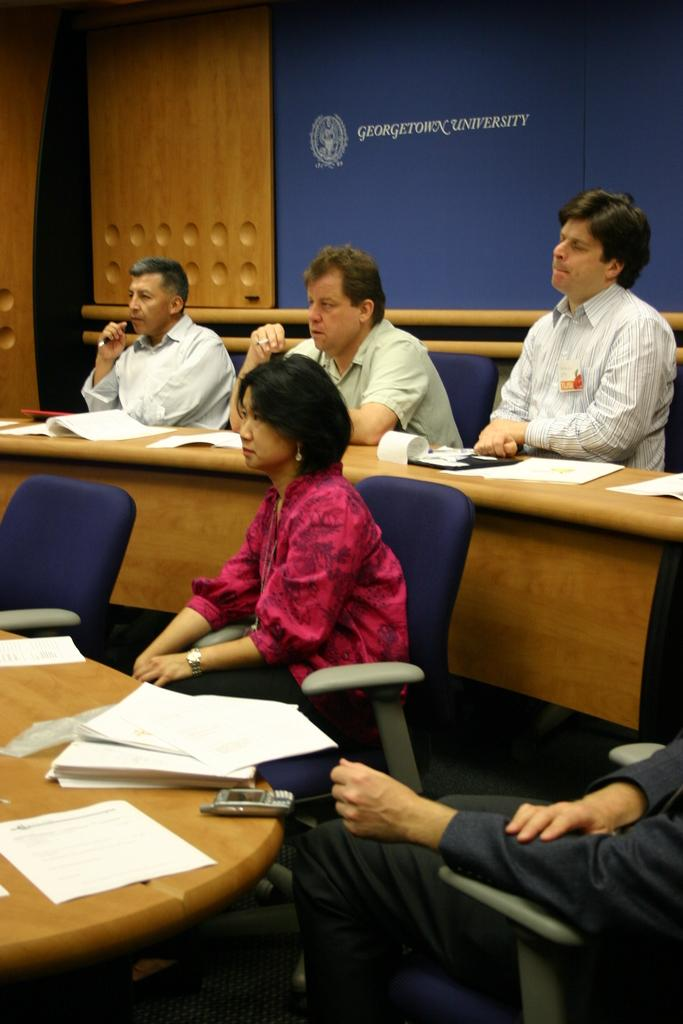How many people are sitting on cars in the image? There are five persons sitting on cars in the image. What objects are on the table in the image? There are papers and a mobile on a table in the image. What can be seen in the background of the image? There is a board visible in the background of the image. Can you tell me how much powder is on the board in the image? There is no mention of powder in the image, so it cannot be determined how much powder is on the board. 